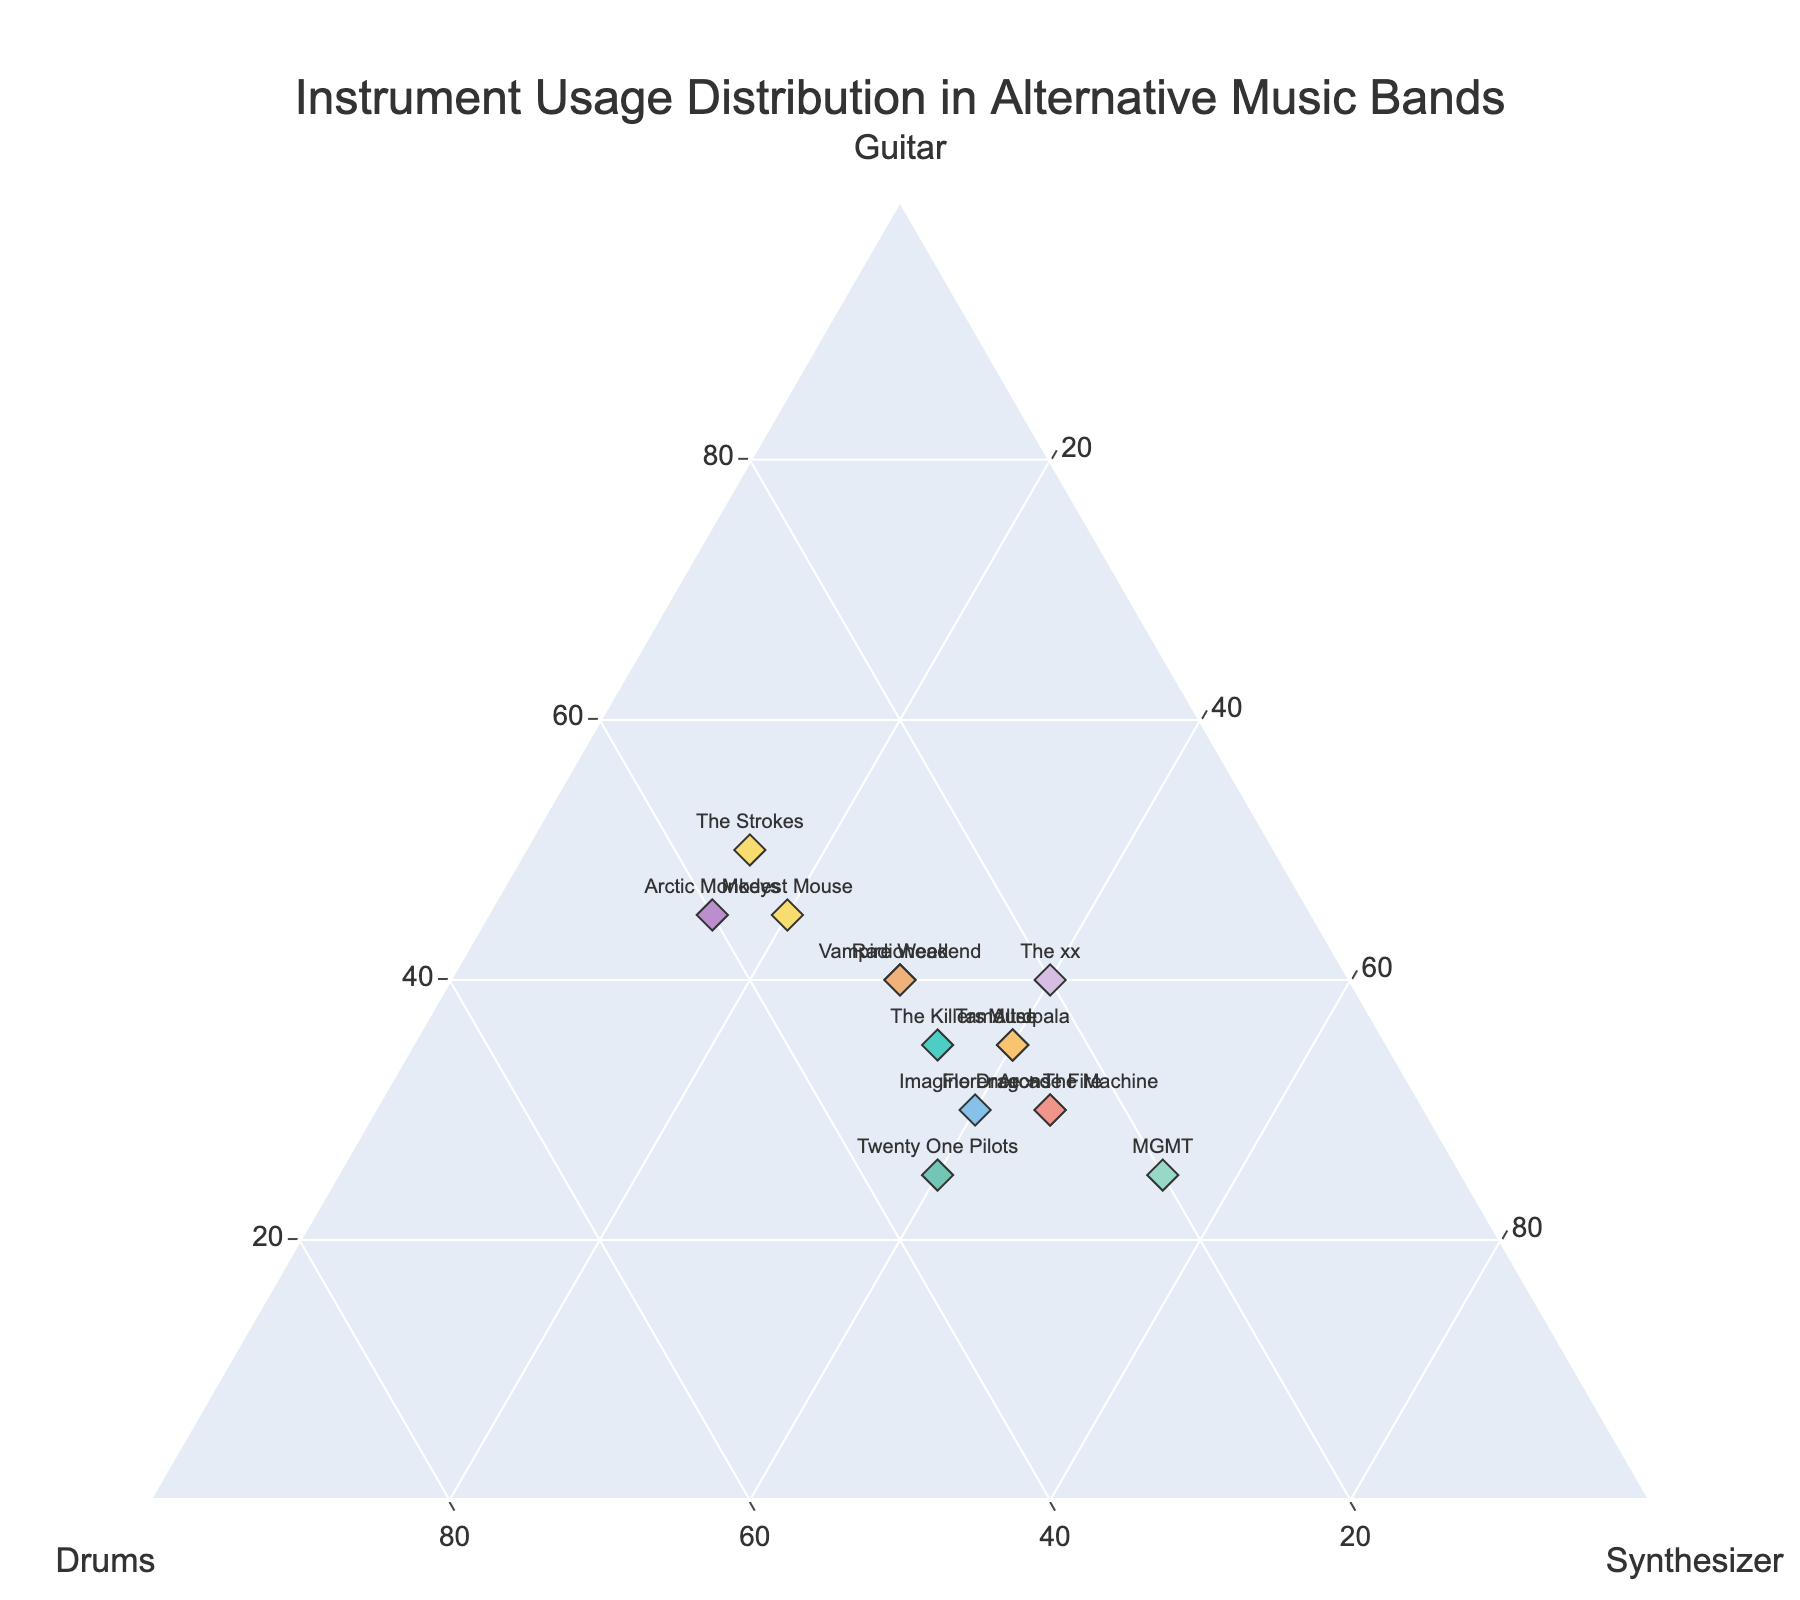What's the title of the plot? The title is usually found at the top of the plot. Titles indicate what the plot is about. Look near the top center of the plot for the text indicating its title.
Answer: Instrument Usage Distribution in Alternative Music Bands How many bands have more emphasis on synthesizers than on guitars? Identify each band’s position in relation to the axes. Check where the synthesizer value is greater than the guitar value for each band.
Answer: 6 (Muse, Arcade Fire, MGMT, Florence + The Machine, Imagine Dragons, Alt-J) Which band has an equal distribution across guitar, drums, and synthesizer? Look for a point where the values for guitar, drums, and synthesizer are equal or nearly equal. Refer to the data if necessary.
Answer: Radiohead and Vampire Weekend Which band has the highest percentage of drums usage? Look at the ternary plot for the band closest to the Drums axis and verify with the data for the highest drums percentage.
Answer: Arctic Monkeys What is the difference between the synthesizer usage and drums usage for Florence + The Machine? Identify the respective percentages for Florence + The Machine in the plot. Calculate the difference between synthesizer and drums values.
Answer: 20% (45% synthesizer - 25% drums) Which bands have more guitar usage than drums and synthesizer combined? Identify bands where the guitar percentage is greater than the sum of drums and synthesizer percentages. Compare these values for each band.
Answer: The Strokes and Arctic Monkeys What is the average percentage of synthesizer usage among all bands? Sum all the synthesizer percentages from the data, and then divide by the number of bands to find the average. (30 + 35 + 40 + 45 + 55 + 15 + 15 + 45 + 40 + 40 + 40 + 40 + 30 + 40 + 20) / 15 = 34.
Answer: 34% Which band is closest in having an even split among all three instruments? Look for a point closest to the central region where guitar, drums, and synthesizer values are nearly equal. Validate by checking the data for close percentages.
Answer: Radiohead 